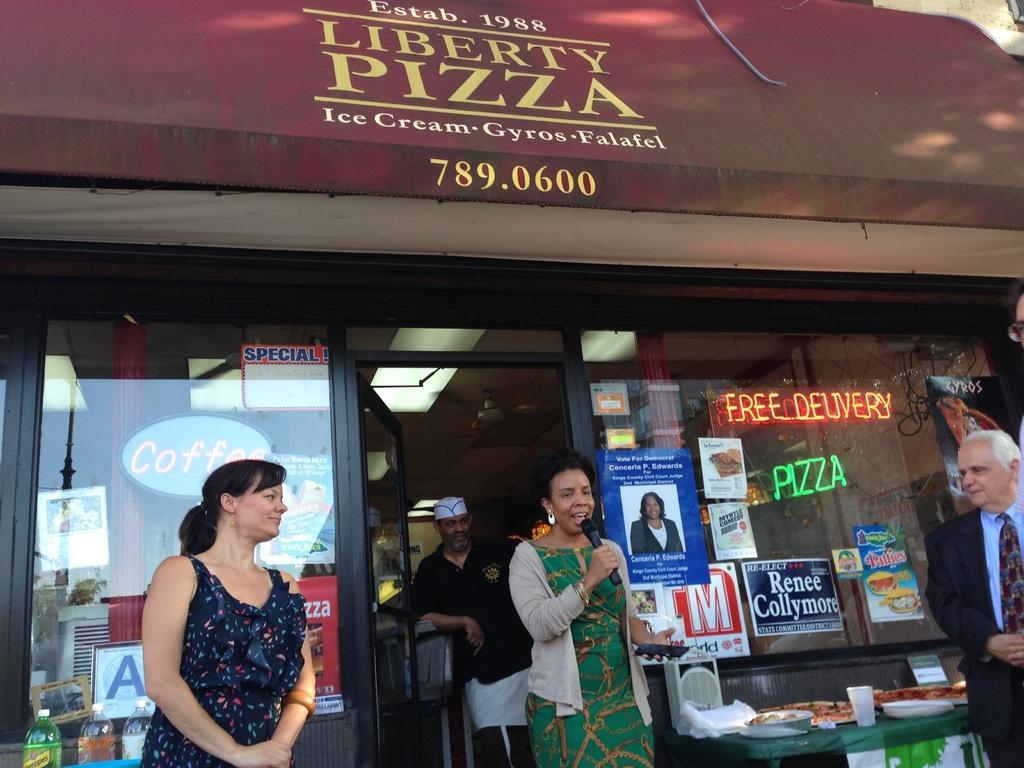Please provide a concise description of this image. In this picture we can see a store. We can see boards, posters, lights, bottles. We can see people. We can see a woman holding a microphone and she is talking. On a table we can see food, plates, glass and objects. 